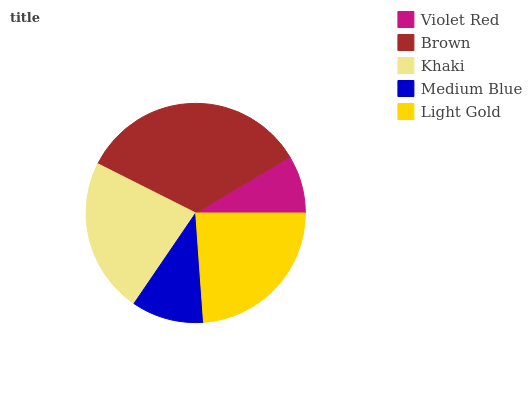Is Violet Red the minimum?
Answer yes or no. Yes. Is Brown the maximum?
Answer yes or no. Yes. Is Khaki the minimum?
Answer yes or no. No. Is Khaki the maximum?
Answer yes or no. No. Is Brown greater than Khaki?
Answer yes or no. Yes. Is Khaki less than Brown?
Answer yes or no. Yes. Is Khaki greater than Brown?
Answer yes or no. No. Is Brown less than Khaki?
Answer yes or no. No. Is Khaki the high median?
Answer yes or no. Yes. Is Khaki the low median?
Answer yes or no. Yes. Is Medium Blue the high median?
Answer yes or no. No. Is Brown the low median?
Answer yes or no. No. 